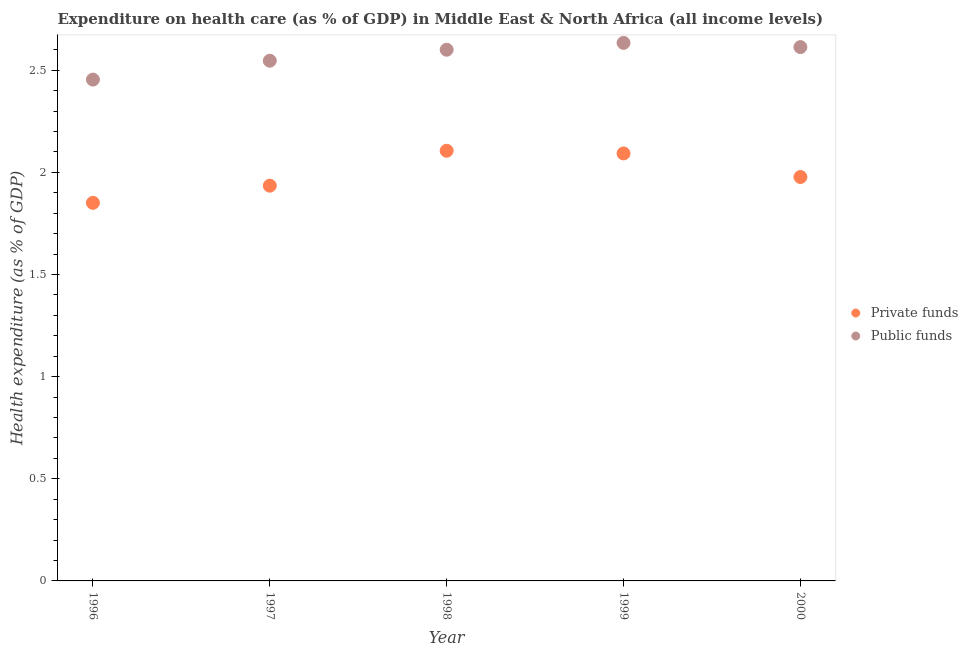Is the number of dotlines equal to the number of legend labels?
Provide a succinct answer. Yes. What is the amount of private funds spent in healthcare in 1996?
Make the answer very short. 1.85. Across all years, what is the maximum amount of public funds spent in healthcare?
Your answer should be compact. 2.63. Across all years, what is the minimum amount of public funds spent in healthcare?
Ensure brevity in your answer.  2.45. In which year was the amount of public funds spent in healthcare maximum?
Make the answer very short. 1999. What is the total amount of public funds spent in healthcare in the graph?
Make the answer very short. 12.85. What is the difference between the amount of public funds spent in healthcare in 1998 and that in 1999?
Your answer should be compact. -0.03. What is the difference between the amount of private funds spent in healthcare in 1997 and the amount of public funds spent in healthcare in 1998?
Your response must be concise. -0.67. What is the average amount of public funds spent in healthcare per year?
Offer a very short reply. 2.57. In the year 1999, what is the difference between the amount of private funds spent in healthcare and amount of public funds spent in healthcare?
Offer a very short reply. -0.54. In how many years, is the amount of public funds spent in healthcare greater than 1.5 %?
Offer a very short reply. 5. What is the ratio of the amount of public funds spent in healthcare in 1999 to that in 2000?
Your answer should be very brief. 1.01. Is the difference between the amount of private funds spent in healthcare in 1998 and 2000 greater than the difference between the amount of public funds spent in healthcare in 1998 and 2000?
Your response must be concise. Yes. What is the difference between the highest and the second highest amount of private funds spent in healthcare?
Provide a succinct answer. 0.01. What is the difference between the highest and the lowest amount of public funds spent in healthcare?
Ensure brevity in your answer.  0.18. In how many years, is the amount of private funds spent in healthcare greater than the average amount of private funds spent in healthcare taken over all years?
Make the answer very short. 2. Is the sum of the amount of public funds spent in healthcare in 1996 and 2000 greater than the maximum amount of private funds spent in healthcare across all years?
Offer a terse response. Yes. Is the amount of private funds spent in healthcare strictly greater than the amount of public funds spent in healthcare over the years?
Keep it short and to the point. No. Is the amount of private funds spent in healthcare strictly less than the amount of public funds spent in healthcare over the years?
Your answer should be compact. Yes. How many dotlines are there?
Your answer should be compact. 2. How many years are there in the graph?
Offer a terse response. 5. What is the difference between two consecutive major ticks on the Y-axis?
Give a very brief answer. 0.5. Where does the legend appear in the graph?
Give a very brief answer. Center right. How many legend labels are there?
Ensure brevity in your answer.  2. What is the title of the graph?
Your answer should be compact. Expenditure on health care (as % of GDP) in Middle East & North Africa (all income levels). Does "Register a business" appear as one of the legend labels in the graph?
Make the answer very short. No. What is the label or title of the Y-axis?
Make the answer very short. Health expenditure (as % of GDP). What is the Health expenditure (as % of GDP) of Private funds in 1996?
Offer a terse response. 1.85. What is the Health expenditure (as % of GDP) of Public funds in 1996?
Ensure brevity in your answer.  2.45. What is the Health expenditure (as % of GDP) in Private funds in 1997?
Ensure brevity in your answer.  1.93. What is the Health expenditure (as % of GDP) in Public funds in 1997?
Offer a very short reply. 2.55. What is the Health expenditure (as % of GDP) in Private funds in 1998?
Ensure brevity in your answer.  2.11. What is the Health expenditure (as % of GDP) of Public funds in 1998?
Your answer should be compact. 2.6. What is the Health expenditure (as % of GDP) in Private funds in 1999?
Give a very brief answer. 2.09. What is the Health expenditure (as % of GDP) of Public funds in 1999?
Provide a succinct answer. 2.63. What is the Health expenditure (as % of GDP) of Private funds in 2000?
Ensure brevity in your answer.  1.98. What is the Health expenditure (as % of GDP) in Public funds in 2000?
Keep it short and to the point. 2.61. Across all years, what is the maximum Health expenditure (as % of GDP) of Private funds?
Provide a short and direct response. 2.11. Across all years, what is the maximum Health expenditure (as % of GDP) of Public funds?
Your answer should be very brief. 2.63. Across all years, what is the minimum Health expenditure (as % of GDP) of Private funds?
Offer a terse response. 1.85. Across all years, what is the minimum Health expenditure (as % of GDP) of Public funds?
Your answer should be very brief. 2.45. What is the total Health expenditure (as % of GDP) in Private funds in the graph?
Offer a terse response. 9.96. What is the total Health expenditure (as % of GDP) of Public funds in the graph?
Your answer should be very brief. 12.85. What is the difference between the Health expenditure (as % of GDP) in Private funds in 1996 and that in 1997?
Make the answer very short. -0.08. What is the difference between the Health expenditure (as % of GDP) of Public funds in 1996 and that in 1997?
Give a very brief answer. -0.09. What is the difference between the Health expenditure (as % of GDP) of Private funds in 1996 and that in 1998?
Provide a short and direct response. -0.25. What is the difference between the Health expenditure (as % of GDP) in Public funds in 1996 and that in 1998?
Offer a very short reply. -0.15. What is the difference between the Health expenditure (as % of GDP) of Private funds in 1996 and that in 1999?
Your response must be concise. -0.24. What is the difference between the Health expenditure (as % of GDP) of Public funds in 1996 and that in 1999?
Offer a very short reply. -0.18. What is the difference between the Health expenditure (as % of GDP) of Private funds in 1996 and that in 2000?
Offer a terse response. -0.13. What is the difference between the Health expenditure (as % of GDP) in Public funds in 1996 and that in 2000?
Offer a terse response. -0.16. What is the difference between the Health expenditure (as % of GDP) in Private funds in 1997 and that in 1998?
Your response must be concise. -0.17. What is the difference between the Health expenditure (as % of GDP) of Public funds in 1997 and that in 1998?
Keep it short and to the point. -0.05. What is the difference between the Health expenditure (as % of GDP) of Private funds in 1997 and that in 1999?
Give a very brief answer. -0.16. What is the difference between the Health expenditure (as % of GDP) of Public funds in 1997 and that in 1999?
Your response must be concise. -0.09. What is the difference between the Health expenditure (as % of GDP) in Private funds in 1997 and that in 2000?
Offer a terse response. -0.04. What is the difference between the Health expenditure (as % of GDP) in Public funds in 1997 and that in 2000?
Provide a succinct answer. -0.07. What is the difference between the Health expenditure (as % of GDP) in Private funds in 1998 and that in 1999?
Keep it short and to the point. 0.01. What is the difference between the Health expenditure (as % of GDP) in Public funds in 1998 and that in 1999?
Keep it short and to the point. -0.03. What is the difference between the Health expenditure (as % of GDP) in Private funds in 1998 and that in 2000?
Provide a short and direct response. 0.13. What is the difference between the Health expenditure (as % of GDP) of Public funds in 1998 and that in 2000?
Offer a very short reply. -0.01. What is the difference between the Health expenditure (as % of GDP) of Private funds in 1999 and that in 2000?
Keep it short and to the point. 0.12. What is the difference between the Health expenditure (as % of GDP) in Public funds in 1999 and that in 2000?
Give a very brief answer. 0.02. What is the difference between the Health expenditure (as % of GDP) in Private funds in 1996 and the Health expenditure (as % of GDP) in Public funds in 1997?
Ensure brevity in your answer.  -0.7. What is the difference between the Health expenditure (as % of GDP) of Private funds in 1996 and the Health expenditure (as % of GDP) of Public funds in 1998?
Make the answer very short. -0.75. What is the difference between the Health expenditure (as % of GDP) of Private funds in 1996 and the Health expenditure (as % of GDP) of Public funds in 1999?
Your answer should be compact. -0.78. What is the difference between the Health expenditure (as % of GDP) of Private funds in 1996 and the Health expenditure (as % of GDP) of Public funds in 2000?
Ensure brevity in your answer.  -0.76. What is the difference between the Health expenditure (as % of GDP) of Private funds in 1997 and the Health expenditure (as % of GDP) of Public funds in 1998?
Your answer should be very brief. -0.67. What is the difference between the Health expenditure (as % of GDP) in Private funds in 1997 and the Health expenditure (as % of GDP) in Public funds in 1999?
Provide a succinct answer. -0.7. What is the difference between the Health expenditure (as % of GDP) of Private funds in 1997 and the Health expenditure (as % of GDP) of Public funds in 2000?
Provide a short and direct response. -0.68. What is the difference between the Health expenditure (as % of GDP) in Private funds in 1998 and the Health expenditure (as % of GDP) in Public funds in 1999?
Your response must be concise. -0.53. What is the difference between the Health expenditure (as % of GDP) in Private funds in 1998 and the Health expenditure (as % of GDP) in Public funds in 2000?
Give a very brief answer. -0.51. What is the difference between the Health expenditure (as % of GDP) in Private funds in 1999 and the Health expenditure (as % of GDP) in Public funds in 2000?
Keep it short and to the point. -0.52. What is the average Health expenditure (as % of GDP) of Private funds per year?
Your answer should be compact. 1.99. What is the average Health expenditure (as % of GDP) of Public funds per year?
Offer a terse response. 2.57. In the year 1996, what is the difference between the Health expenditure (as % of GDP) of Private funds and Health expenditure (as % of GDP) of Public funds?
Offer a very short reply. -0.6. In the year 1997, what is the difference between the Health expenditure (as % of GDP) of Private funds and Health expenditure (as % of GDP) of Public funds?
Offer a terse response. -0.61. In the year 1998, what is the difference between the Health expenditure (as % of GDP) of Private funds and Health expenditure (as % of GDP) of Public funds?
Your response must be concise. -0.49. In the year 1999, what is the difference between the Health expenditure (as % of GDP) of Private funds and Health expenditure (as % of GDP) of Public funds?
Your answer should be compact. -0.54. In the year 2000, what is the difference between the Health expenditure (as % of GDP) in Private funds and Health expenditure (as % of GDP) in Public funds?
Keep it short and to the point. -0.64. What is the ratio of the Health expenditure (as % of GDP) of Private funds in 1996 to that in 1997?
Your answer should be compact. 0.96. What is the ratio of the Health expenditure (as % of GDP) in Public funds in 1996 to that in 1997?
Ensure brevity in your answer.  0.96. What is the ratio of the Health expenditure (as % of GDP) in Private funds in 1996 to that in 1998?
Your response must be concise. 0.88. What is the ratio of the Health expenditure (as % of GDP) of Public funds in 1996 to that in 1998?
Your answer should be compact. 0.94. What is the ratio of the Health expenditure (as % of GDP) in Private funds in 1996 to that in 1999?
Provide a succinct answer. 0.88. What is the ratio of the Health expenditure (as % of GDP) in Public funds in 1996 to that in 1999?
Provide a short and direct response. 0.93. What is the ratio of the Health expenditure (as % of GDP) of Private funds in 1996 to that in 2000?
Provide a short and direct response. 0.94. What is the ratio of the Health expenditure (as % of GDP) in Public funds in 1996 to that in 2000?
Your answer should be compact. 0.94. What is the ratio of the Health expenditure (as % of GDP) of Private funds in 1997 to that in 1998?
Provide a short and direct response. 0.92. What is the ratio of the Health expenditure (as % of GDP) of Public funds in 1997 to that in 1998?
Provide a short and direct response. 0.98. What is the ratio of the Health expenditure (as % of GDP) in Private funds in 1997 to that in 1999?
Offer a terse response. 0.92. What is the ratio of the Health expenditure (as % of GDP) in Public funds in 1997 to that in 1999?
Your response must be concise. 0.97. What is the ratio of the Health expenditure (as % of GDP) in Private funds in 1997 to that in 2000?
Provide a short and direct response. 0.98. What is the ratio of the Health expenditure (as % of GDP) of Public funds in 1997 to that in 2000?
Give a very brief answer. 0.97. What is the ratio of the Health expenditure (as % of GDP) of Public funds in 1998 to that in 1999?
Ensure brevity in your answer.  0.99. What is the ratio of the Health expenditure (as % of GDP) of Private funds in 1998 to that in 2000?
Offer a terse response. 1.06. What is the ratio of the Health expenditure (as % of GDP) in Private funds in 1999 to that in 2000?
Make the answer very short. 1.06. What is the ratio of the Health expenditure (as % of GDP) of Public funds in 1999 to that in 2000?
Keep it short and to the point. 1.01. What is the difference between the highest and the second highest Health expenditure (as % of GDP) in Private funds?
Make the answer very short. 0.01. What is the difference between the highest and the second highest Health expenditure (as % of GDP) in Public funds?
Offer a very short reply. 0.02. What is the difference between the highest and the lowest Health expenditure (as % of GDP) of Private funds?
Provide a succinct answer. 0.25. What is the difference between the highest and the lowest Health expenditure (as % of GDP) in Public funds?
Your response must be concise. 0.18. 